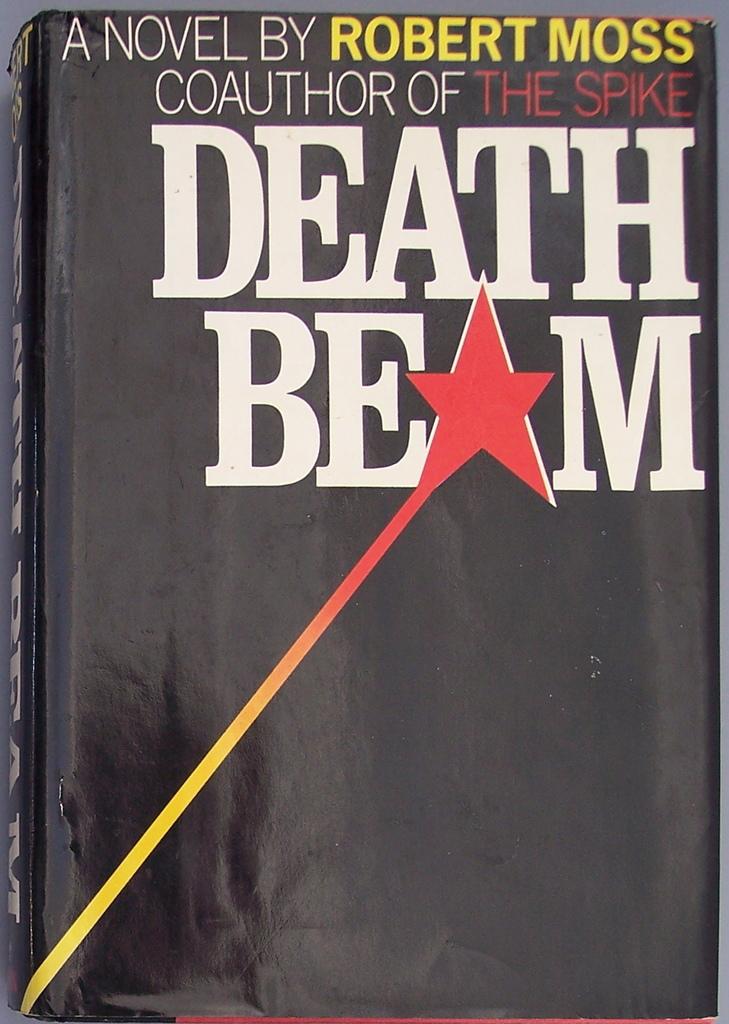Between what letters is the red star located ?
Your answer should be compact. E, m. Who wrote this book?
Provide a succinct answer. Robert moss. 